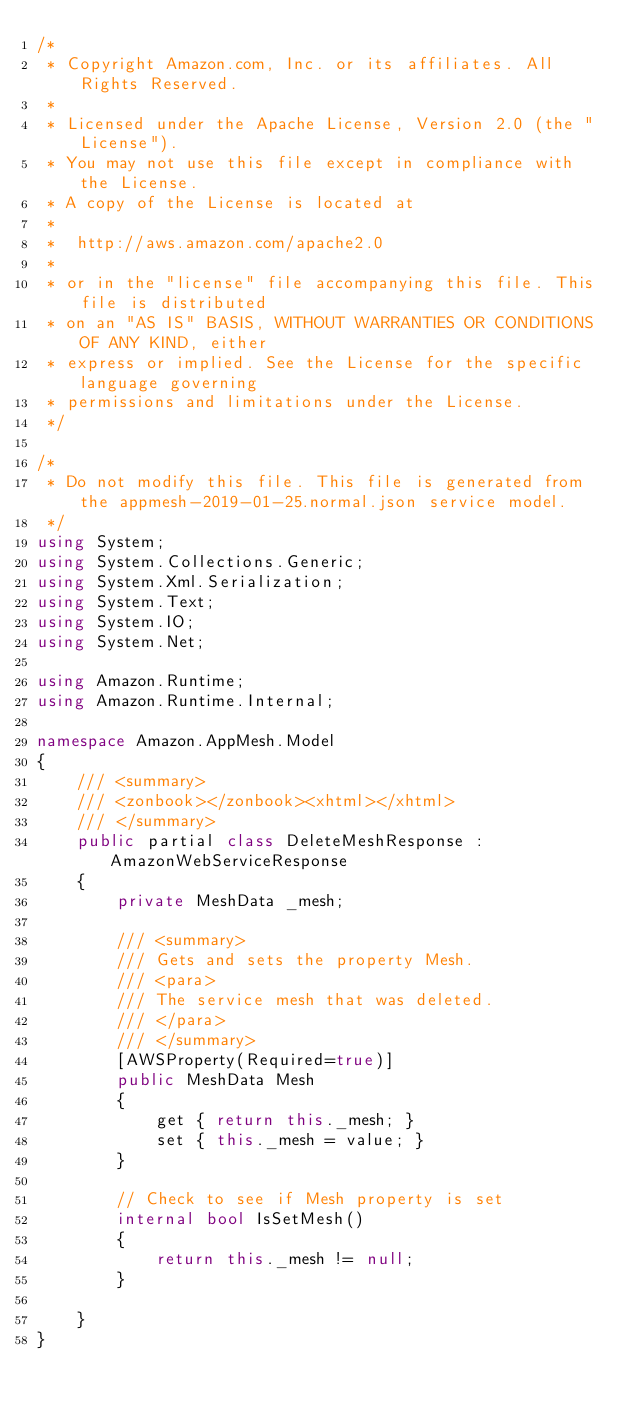Convert code to text. <code><loc_0><loc_0><loc_500><loc_500><_C#_>/*
 * Copyright Amazon.com, Inc. or its affiliates. All Rights Reserved.
 * 
 * Licensed under the Apache License, Version 2.0 (the "License").
 * You may not use this file except in compliance with the License.
 * A copy of the License is located at
 * 
 *  http://aws.amazon.com/apache2.0
 * 
 * or in the "license" file accompanying this file. This file is distributed
 * on an "AS IS" BASIS, WITHOUT WARRANTIES OR CONDITIONS OF ANY KIND, either
 * express or implied. See the License for the specific language governing
 * permissions and limitations under the License.
 */

/*
 * Do not modify this file. This file is generated from the appmesh-2019-01-25.normal.json service model.
 */
using System;
using System.Collections.Generic;
using System.Xml.Serialization;
using System.Text;
using System.IO;
using System.Net;

using Amazon.Runtime;
using Amazon.Runtime.Internal;

namespace Amazon.AppMesh.Model
{
    /// <summary>
    /// <zonbook></zonbook><xhtml></xhtml>
    /// </summary>
    public partial class DeleteMeshResponse : AmazonWebServiceResponse
    {
        private MeshData _mesh;

        /// <summary>
        /// Gets and sets the property Mesh. 
        /// <para>
        /// The service mesh that was deleted.
        /// </para>
        /// </summary>
        [AWSProperty(Required=true)]
        public MeshData Mesh
        {
            get { return this._mesh; }
            set { this._mesh = value; }
        }

        // Check to see if Mesh property is set
        internal bool IsSetMesh()
        {
            return this._mesh != null;
        }

    }
}</code> 